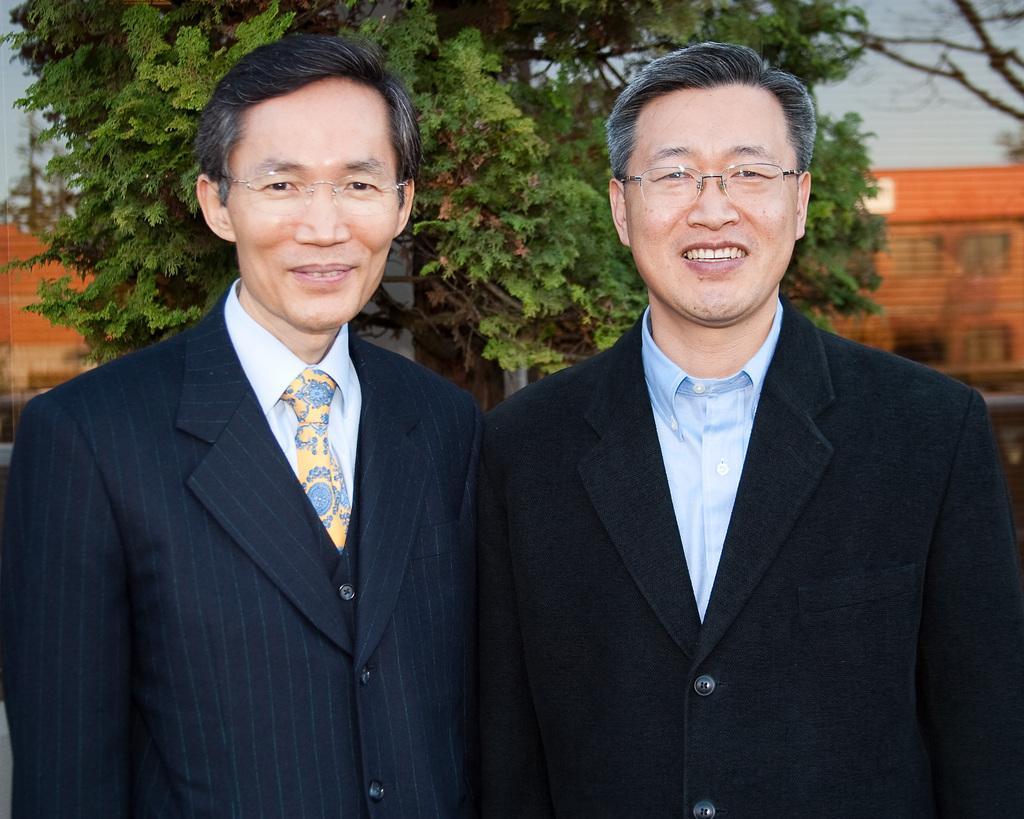How many people are in the image? There are two persons in the image. What are the persons wearing? The persons are wearing suits. What can be seen in the background of the image? There is a tree and houses in the background of the image. What type of competition is taking place in the image? There is no competition present in the image. Can you provide an example of a society that the persons in the image might belong to? There is not enough information in the image to determine the society or culture that the persons belong to. 